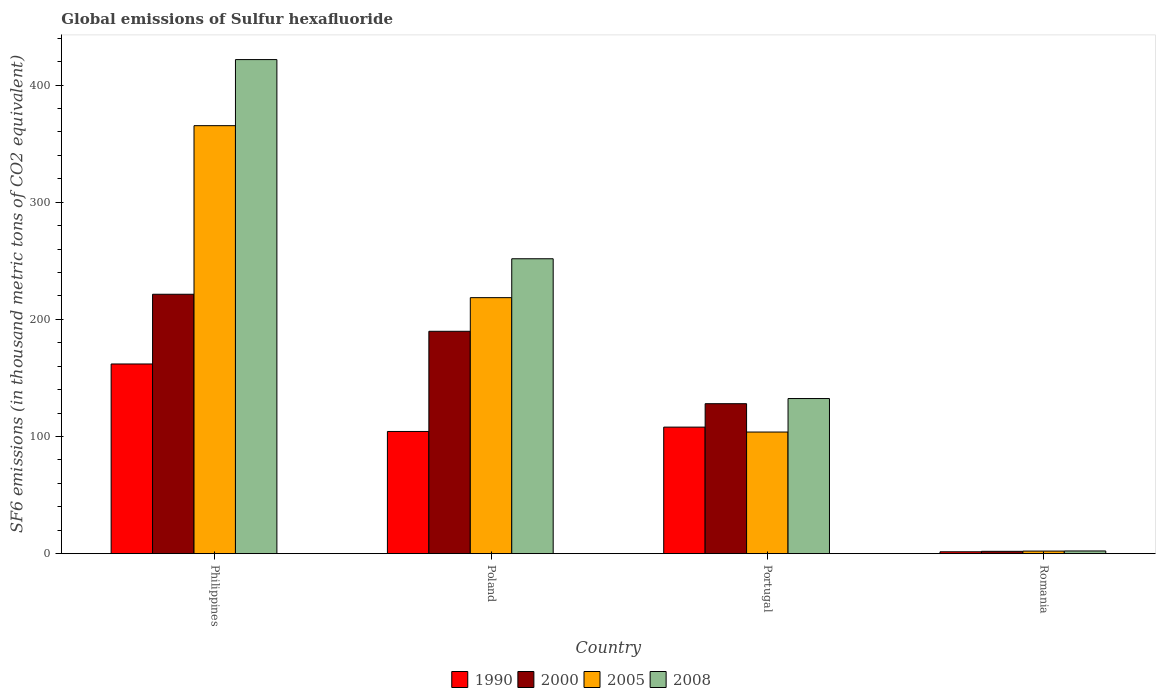Are the number of bars per tick equal to the number of legend labels?
Your answer should be compact. Yes. What is the label of the 3rd group of bars from the left?
Give a very brief answer. Portugal. What is the global emissions of Sulfur hexafluoride in 1990 in Portugal?
Your response must be concise. 108. Across all countries, what is the maximum global emissions of Sulfur hexafluoride in 2008?
Keep it short and to the point. 421.7. Across all countries, what is the minimum global emissions of Sulfur hexafluoride in 2005?
Give a very brief answer. 2.2. In which country was the global emissions of Sulfur hexafluoride in 2008 minimum?
Give a very brief answer. Romania. What is the total global emissions of Sulfur hexafluoride in 1990 in the graph?
Give a very brief answer. 375.8. What is the difference between the global emissions of Sulfur hexafluoride in 2000 in Portugal and that in Romania?
Ensure brevity in your answer.  126. What is the difference between the global emissions of Sulfur hexafluoride in 2008 in Philippines and the global emissions of Sulfur hexafluoride in 2000 in Romania?
Provide a succinct answer. 419.7. What is the average global emissions of Sulfur hexafluoride in 2005 per country?
Your response must be concise. 172.45. What is the difference between the global emissions of Sulfur hexafluoride of/in 2008 and global emissions of Sulfur hexafluoride of/in 1990 in Philippines?
Offer a very short reply. 259.8. In how many countries, is the global emissions of Sulfur hexafluoride in 2000 greater than 280 thousand metric tons?
Your answer should be compact. 0. What is the ratio of the global emissions of Sulfur hexafluoride in 2005 in Portugal to that in Romania?
Give a very brief answer. 47.18. Is the difference between the global emissions of Sulfur hexafluoride in 2008 in Philippines and Poland greater than the difference between the global emissions of Sulfur hexafluoride in 1990 in Philippines and Poland?
Provide a succinct answer. Yes. What is the difference between the highest and the second highest global emissions of Sulfur hexafluoride in 1990?
Your answer should be compact. -57.6. What is the difference between the highest and the lowest global emissions of Sulfur hexafluoride in 2000?
Provide a succinct answer. 219.4. In how many countries, is the global emissions of Sulfur hexafluoride in 2008 greater than the average global emissions of Sulfur hexafluoride in 2008 taken over all countries?
Your answer should be very brief. 2. Is the sum of the global emissions of Sulfur hexafluoride in 2008 in Poland and Portugal greater than the maximum global emissions of Sulfur hexafluoride in 1990 across all countries?
Your answer should be compact. Yes. Is it the case that in every country, the sum of the global emissions of Sulfur hexafluoride in 1990 and global emissions of Sulfur hexafluoride in 2005 is greater than the sum of global emissions of Sulfur hexafluoride in 2008 and global emissions of Sulfur hexafluoride in 2000?
Offer a very short reply. No. What does the 4th bar from the left in Philippines represents?
Your answer should be very brief. 2008. What does the 2nd bar from the right in Philippines represents?
Offer a very short reply. 2005. Is it the case that in every country, the sum of the global emissions of Sulfur hexafluoride in 2000 and global emissions of Sulfur hexafluoride in 2008 is greater than the global emissions of Sulfur hexafluoride in 2005?
Ensure brevity in your answer.  Yes. What is the difference between two consecutive major ticks on the Y-axis?
Your answer should be compact. 100. Does the graph contain any zero values?
Make the answer very short. No. Where does the legend appear in the graph?
Give a very brief answer. Bottom center. What is the title of the graph?
Your answer should be compact. Global emissions of Sulfur hexafluoride. Does "1968" appear as one of the legend labels in the graph?
Offer a terse response. No. What is the label or title of the X-axis?
Ensure brevity in your answer.  Country. What is the label or title of the Y-axis?
Your answer should be very brief. SF6 emissions (in thousand metric tons of CO2 equivalent). What is the SF6 emissions (in thousand metric tons of CO2 equivalent) in 1990 in Philippines?
Your response must be concise. 161.9. What is the SF6 emissions (in thousand metric tons of CO2 equivalent) in 2000 in Philippines?
Offer a very short reply. 221.4. What is the SF6 emissions (in thousand metric tons of CO2 equivalent) in 2005 in Philippines?
Offer a very short reply. 365.3. What is the SF6 emissions (in thousand metric tons of CO2 equivalent) of 2008 in Philippines?
Keep it short and to the point. 421.7. What is the SF6 emissions (in thousand metric tons of CO2 equivalent) of 1990 in Poland?
Your response must be concise. 104.3. What is the SF6 emissions (in thousand metric tons of CO2 equivalent) in 2000 in Poland?
Give a very brief answer. 189.8. What is the SF6 emissions (in thousand metric tons of CO2 equivalent) in 2005 in Poland?
Your response must be concise. 218.5. What is the SF6 emissions (in thousand metric tons of CO2 equivalent) in 2008 in Poland?
Offer a terse response. 251.7. What is the SF6 emissions (in thousand metric tons of CO2 equivalent) in 1990 in Portugal?
Ensure brevity in your answer.  108. What is the SF6 emissions (in thousand metric tons of CO2 equivalent) in 2000 in Portugal?
Your answer should be compact. 128. What is the SF6 emissions (in thousand metric tons of CO2 equivalent) of 2005 in Portugal?
Your answer should be very brief. 103.8. What is the SF6 emissions (in thousand metric tons of CO2 equivalent) of 2008 in Portugal?
Ensure brevity in your answer.  132.4. What is the SF6 emissions (in thousand metric tons of CO2 equivalent) in 2008 in Romania?
Provide a succinct answer. 2.3. Across all countries, what is the maximum SF6 emissions (in thousand metric tons of CO2 equivalent) in 1990?
Your response must be concise. 161.9. Across all countries, what is the maximum SF6 emissions (in thousand metric tons of CO2 equivalent) in 2000?
Offer a very short reply. 221.4. Across all countries, what is the maximum SF6 emissions (in thousand metric tons of CO2 equivalent) of 2005?
Provide a succinct answer. 365.3. Across all countries, what is the maximum SF6 emissions (in thousand metric tons of CO2 equivalent) of 2008?
Make the answer very short. 421.7. Across all countries, what is the minimum SF6 emissions (in thousand metric tons of CO2 equivalent) of 1990?
Offer a very short reply. 1.6. Across all countries, what is the minimum SF6 emissions (in thousand metric tons of CO2 equivalent) in 2000?
Give a very brief answer. 2. Across all countries, what is the minimum SF6 emissions (in thousand metric tons of CO2 equivalent) of 2005?
Keep it short and to the point. 2.2. What is the total SF6 emissions (in thousand metric tons of CO2 equivalent) in 1990 in the graph?
Your response must be concise. 375.8. What is the total SF6 emissions (in thousand metric tons of CO2 equivalent) of 2000 in the graph?
Provide a short and direct response. 541.2. What is the total SF6 emissions (in thousand metric tons of CO2 equivalent) in 2005 in the graph?
Offer a very short reply. 689.8. What is the total SF6 emissions (in thousand metric tons of CO2 equivalent) in 2008 in the graph?
Your answer should be compact. 808.1. What is the difference between the SF6 emissions (in thousand metric tons of CO2 equivalent) in 1990 in Philippines and that in Poland?
Provide a short and direct response. 57.6. What is the difference between the SF6 emissions (in thousand metric tons of CO2 equivalent) of 2000 in Philippines and that in Poland?
Your answer should be compact. 31.6. What is the difference between the SF6 emissions (in thousand metric tons of CO2 equivalent) in 2005 in Philippines and that in Poland?
Your answer should be compact. 146.8. What is the difference between the SF6 emissions (in thousand metric tons of CO2 equivalent) of 2008 in Philippines and that in Poland?
Make the answer very short. 170. What is the difference between the SF6 emissions (in thousand metric tons of CO2 equivalent) in 1990 in Philippines and that in Portugal?
Your response must be concise. 53.9. What is the difference between the SF6 emissions (in thousand metric tons of CO2 equivalent) of 2000 in Philippines and that in Portugal?
Give a very brief answer. 93.4. What is the difference between the SF6 emissions (in thousand metric tons of CO2 equivalent) in 2005 in Philippines and that in Portugal?
Provide a succinct answer. 261.5. What is the difference between the SF6 emissions (in thousand metric tons of CO2 equivalent) of 2008 in Philippines and that in Portugal?
Offer a terse response. 289.3. What is the difference between the SF6 emissions (in thousand metric tons of CO2 equivalent) in 1990 in Philippines and that in Romania?
Ensure brevity in your answer.  160.3. What is the difference between the SF6 emissions (in thousand metric tons of CO2 equivalent) of 2000 in Philippines and that in Romania?
Keep it short and to the point. 219.4. What is the difference between the SF6 emissions (in thousand metric tons of CO2 equivalent) of 2005 in Philippines and that in Romania?
Keep it short and to the point. 363.1. What is the difference between the SF6 emissions (in thousand metric tons of CO2 equivalent) of 2008 in Philippines and that in Romania?
Your answer should be very brief. 419.4. What is the difference between the SF6 emissions (in thousand metric tons of CO2 equivalent) in 2000 in Poland and that in Portugal?
Ensure brevity in your answer.  61.8. What is the difference between the SF6 emissions (in thousand metric tons of CO2 equivalent) of 2005 in Poland and that in Portugal?
Offer a terse response. 114.7. What is the difference between the SF6 emissions (in thousand metric tons of CO2 equivalent) of 2008 in Poland and that in Portugal?
Keep it short and to the point. 119.3. What is the difference between the SF6 emissions (in thousand metric tons of CO2 equivalent) of 1990 in Poland and that in Romania?
Your response must be concise. 102.7. What is the difference between the SF6 emissions (in thousand metric tons of CO2 equivalent) in 2000 in Poland and that in Romania?
Ensure brevity in your answer.  187.8. What is the difference between the SF6 emissions (in thousand metric tons of CO2 equivalent) in 2005 in Poland and that in Romania?
Provide a succinct answer. 216.3. What is the difference between the SF6 emissions (in thousand metric tons of CO2 equivalent) in 2008 in Poland and that in Romania?
Your answer should be compact. 249.4. What is the difference between the SF6 emissions (in thousand metric tons of CO2 equivalent) in 1990 in Portugal and that in Romania?
Give a very brief answer. 106.4. What is the difference between the SF6 emissions (in thousand metric tons of CO2 equivalent) of 2000 in Portugal and that in Romania?
Offer a terse response. 126. What is the difference between the SF6 emissions (in thousand metric tons of CO2 equivalent) in 2005 in Portugal and that in Romania?
Provide a succinct answer. 101.6. What is the difference between the SF6 emissions (in thousand metric tons of CO2 equivalent) of 2008 in Portugal and that in Romania?
Make the answer very short. 130.1. What is the difference between the SF6 emissions (in thousand metric tons of CO2 equivalent) of 1990 in Philippines and the SF6 emissions (in thousand metric tons of CO2 equivalent) of 2000 in Poland?
Your answer should be compact. -27.9. What is the difference between the SF6 emissions (in thousand metric tons of CO2 equivalent) of 1990 in Philippines and the SF6 emissions (in thousand metric tons of CO2 equivalent) of 2005 in Poland?
Ensure brevity in your answer.  -56.6. What is the difference between the SF6 emissions (in thousand metric tons of CO2 equivalent) of 1990 in Philippines and the SF6 emissions (in thousand metric tons of CO2 equivalent) of 2008 in Poland?
Your answer should be very brief. -89.8. What is the difference between the SF6 emissions (in thousand metric tons of CO2 equivalent) in 2000 in Philippines and the SF6 emissions (in thousand metric tons of CO2 equivalent) in 2005 in Poland?
Provide a succinct answer. 2.9. What is the difference between the SF6 emissions (in thousand metric tons of CO2 equivalent) in 2000 in Philippines and the SF6 emissions (in thousand metric tons of CO2 equivalent) in 2008 in Poland?
Your answer should be compact. -30.3. What is the difference between the SF6 emissions (in thousand metric tons of CO2 equivalent) of 2005 in Philippines and the SF6 emissions (in thousand metric tons of CO2 equivalent) of 2008 in Poland?
Your response must be concise. 113.6. What is the difference between the SF6 emissions (in thousand metric tons of CO2 equivalent) in 1990 in Philippines and the SF6 emissions (in thousand metric tons of CO2 equivalent) in 2000 in Portugal?
Your answer should be very brief. 33.9. What is the difference between the SF6 emissions (in thousand metric tons of CO2 equivalent) in 1990 in Philippines and the SF6 emissions (in thousand metric tons of CO2 equivalent) in 2005 in Portugal?
Give a very brief answer. 58.1. What is the difference between the SF6 emissions (in thousand metric tons of CO2 equivalent) in 1990 in Philippines and the SF6 emissions (in thousand metric tons of CO2 equivalent) in 2008 in Portugal?
Keep it short and to the point. 29.5. What is the difference between the SF6 emissions (in thousand metric tons of CO2 equivalent) of 2000 in Philippines and the SF6 emissions (in thousand metric tons of CO2 equivalent) of 2005 in Portugal?
Your response must be concise. 117.6. What is the difference between the SF6 emissions (in thousand metric tons of CO2 equivalent) in 2000 in Philippines and the SF6 emissions (in thousand metric tons of CO2 equivalent) in 2008 in Portugal?
Make the answer very short. 89. What is the difference between the SF6 emissions (in thousand metric tons of CO2 equivalent) in 2005 in Philippines and the SF6 emissions (in thousand metric tons of CO2 equivalent) in 2008 in Portugal?
Your answer should be very brief. 232.9. What is the difference between the SF6 emissions (in thousand metric tons of CO2 equivalent) in 1990 in Philippines and the SF6 emissions (in thousand metric tons of CO2 equivalent) in 2000 in Romania?
Provide a short and direct response. 159.9. What is the difference between the SF6 emissions (in thousand metric tons of CO2 equivalent) in 1990 in Philippines and the SF6 emissions (in thousand metric tons of CO2 equivalent) in 2005 in Romania?
Offer a very short reply. 159.7. What is the difference between the SF6 emissions (in thousand metric tons of CO2 equivalent) in 1990 in Philippines and the SF6 emissions (in thousand metric tons of CO2 equivalent) in 2008 in Romania?
Provide a short and direct response. 159.6. What is the difference between the SF6 emissions (in thousand metric tons of CO2 equivalent) of 2000 in Philippines and the SF6 emissions (in thousand metric tons of CO2 equivalent) of 2005 in Romania?
Give a very brief answer. 219.2. What is the difference between the SF6 emissions (in thousand metric tons of CO2 equivalent) in 2000 in Philippines and the SF6 emissions (in thousand metric tons of CO2 equivalent) in 2008 in Romania?
Your response must be concise. 219.1. What is the difference between the SF6 emissions (in thousand metric tons of CO2 equivalent) of 2005 in Philippines and the SF6 emissions (in thousand metric tons of CO2 equivalent) of 2008 in Romania?
Offer a very short reply. 363. What is the difference between the SF6 emissions (in thousand metric tons of CO2 equivalent) in 1990 in Poland and the SF6 emissions (in thousand metric tons of CO2 equivalent) in 2000 in Portugal?
Offer a very short reply. -23.7. What is the difference between the SF6 emissions (in thousand metric tons of CO2 equivalent) of 1990 in Poland and the SF6 emissions (in thousand metric tons of CO2 equivalent) of 2005 in Portugal?
Your answer should be compact. 0.5. What is the difference between the SF6 emissions (in thousand metric tons of CO2 equivalent) of 1990 in Poland and the SF6 emissions (in thousand metric tons of CO2 equivalent) of 2008 in Portugal?
Keep it short and to the point. -28.1. What is the difference between the SF6 emissions (in thousand metric tons of CO2 equivalent) in 2000 in Poland and the SF6 emissions (in thousand metric tons of CO2 equivalent) in 2005 in Portugal?
Your answer should be very brief. 86. What is the difference between the SF6 emissions (in thousand metric tons of CO2 equivalent) of 2000 in Poland and the SF6 emissions (in thousand metric tons of CO2 equivalent) of 2008 in Portugal?
Offer a very short reply. 57.4. What is the difference between the SF6 emissions (in thousand metric tons of CO2 equivalent) in 2005 in Poland and the SF6 emissions (in thousand metric tons of CO2 equivalent) in 2008 in Portugal?
Keep it short and to the point. 86.1. What is the difference between the SF6 emissions (in thousand metric tons of CO2 equivalent) of 1990 in Poland and the SF6 emissions (in thousand metric tons of CO2 equivalent) of 2000 in Romania?
Your response must be concise. 102.3. What is the difference between the SF6 emissions (in thousand metric tons of CO2 equivalent) in 1990 in Poland and the SF6 emissions (in thousand metric tons of CO2 equivalent) in 2005 in Romania?
Offer a very short reply. 102.1. What is the difference between the SF6 emissions (in thousand metric tons of CO2 equivalent) of 1990 in Poland and the SF6 emissions (in thousand metric tons of CO2 equivalent) of 2008 in Romania?
Give a very brief answer. 102. What is the difference between the SF6 emissions (in thousand metric tons of CO2 equivalent) of 2000 in Poland and the SF6 emissions (in thousand metric tons of CO2 equivalent) of 2005 in Romania?
Ensure brevity in your answer.  187.6. What is the difference between the SF6 emissions (in thousand metric tons of CO2 equivalent) of 2000 in Poland and the SF6 emissions (in thousand metric tons of CO2 equivalent) of 2008 in Romania?
Your answer should be very brief. 187.5. What is the difference between the SF6 emissions (in thousand metric tons of CO2 equivalent) of 2005 in Poland and the SF6 emissions (in thousand metric tons of CO2 equivalent) of 2008 in Romania?
Offer a very short reply. 216.2. What is the difference between the SF6 emissions (in thousand metric tons of CO2 equivalent) of 1990 in Portugal and the SF6 emissions (in thousand metric tons of CO2 equivalent) of 2000 in Romania?
Give a very brief answer. 106. What is the difference between the SF6 emissions (in thousand metric tons of CO2 equivalent) of 1990 in Portugal and the SF6 emissions (in thousand metric tons of CO2 equivalent) of 2005 in Romania?
Your answer should be compact. 105.8. What is the difference between the SF6 emissions (in thousand metric tons of CO2 equivalent) in 1990 in Portugal and the SF6 emissions (in thousand metric tons of CO2 equivalent) in 2008 in Romania?
Your answer should be compact. 105.7. What is the difference between the SF6 emissions (in thousand metric tons of CO2 equivalent) in 2000 in Portugal and the SF6 emissions (in thousand metric tons of CO2 equivalent) in 2005 in Romania?
Ensure brevity in your answer.  125.8. What is the difference between the SF6 emissions (in thousand metric tons of CO2 equivalent) in 2000 in Portugal and the SF6 emissions (in thousand metric tons of CO2 equivalent) in 2008 in Romania?
Provide a short and direct response. 125.7. What is the difference between the SF6 emissions (in thousand metric tons of CO2 equivalent) of 2005 in Portugal and the SF6 emissions (in thousand metric tons of CO2 equivalent) of 2008 in Romania?
Provide a short and direct response. 101.5. What is the average SF6 emissions (in thousand metric tons of CO2 equivalent) in 1990 per country?
Keep it short and to the point. 93.95. What is the average SF6 emissions (in thousand metric tons of CO2 equivalent) of 2000 per country?
Make the answer very short. 135.3. What is the average SF6 emissions (in thousand metric tons of CO2 equivalent) of 2005 per country?
Ensure brevity in your answer.  172.45. What is the average SF6 emissions (in thousand metric tons of CO2 equivalent) of 2008 per country?
Your answer should be very brief. 202.03. What is the difference between the SF6 emissions (in thousand metric tons of CO2 equivalent) of 1990 and SF6 emissions (in thousand metric tons of CO2 equivalent) of 2000 in Philippines?
Your answer should be compact. -59.5. What is the difference between the SF6 emissions (in thousand metric tons of CO2 equivalent) in 1990 and SF6 emissions (in thousand metric tons of CO2 equivalent) in 2005 in Philippines?
Give a very brief answer. -203.4. What is the difference between the SF6 emissions (in thousand metric tons of CO2 equivalent) in 1990 and SF6 emissions (in thousand metric tons of CO2 equivalent) in 2008 in Philippines?
Give a very brief answer. -259.8. What is the difference between the SF6 emissions (in thousand metric tons of CO2 equivalent) in 2000 and SF6 emissions (in thousand metric tons of CO2 equivalent) in 2005 in Philippines?
Your answer should be compact. -143.9. What is the difference between the SF6 emissions (in thousand metric tons of CO2 equivalent) of 2000 and SF6 emissions (in thousand metric tons of CO2 equivalent) of 2008 in Philippines?
Your answer should be compact. -200.3. What is the difference between the SF6 emissions (in thousand metric tons of CO2 equivalent) of 2005 and SF6 emissions (in thousand metric tons of CO2 equivalent) of 2008 in Philippines?
Your response must be concise. -56.4. What is the difference between the SF6 emissions (in thousand metric tons of CO2 equivalent) in 1990 and SF6 emissions (in thousand metric tons of CO2 equivalent) in 2000 in Poland?
Offer a terse response. -85.5. What is the difference between the SF6 emissions (in thousand metric tons of CO2 equivalent) of 1990 and SF6 emissions (in thousand metric tons of CO2 equivalent) of 2005 in Poland?
Your response must be concise. -114.2. What is the difference between the SF6 emissions (in thousand metric tons of CO2 equivalent) of 1990 and SF6 emissions (in thousand metric tons of CO2 equivalent) of 2008 in Poland?
Provide a short and direct response. -147.4. What is the difference between the SF6 emissions (in thousand metric tons of CO2 equivalent) of 2000 and SF6 emissions (in thousand metric tons of CO2 equivalent) of 2005 in Poland?
Your answer should be compact. -28.7. What is the difference between the SF6 emissions (in thousand metric tons of CO2 equivalent) in 2000 and SF6 emissions (in thousand metric tons of CO2 equivalent) in 2008 in Poland?
Your answer should be compact. -61.9. What is the difference between the SF6 emissions (in thousand metric tons of CO2 equivalent) in 2005 and SF6 emissions (in thousand metric tons of CO2 equivalent) in 2008 in Poland?
Keep it short and to the point. -33.2. What is the difference between the SF6 emissions (in thousand metric tons of CO2 equivalent) in 1990 and SF6 emissions (in thousand metric tons of CO2 equivalent) in 2000 in Portugal?
Ensure brevity in your answer.  -20. What is the difference between the SF6 emissions (in thousand metric tons of CO2 equivalent) in 1990 and SF6 emissions (in thousand metric tons of CO2 equivalent) in 2008 in Portugal?
Provide a short and direct response. -24.4. What is the difference between the SF6 emissions (in thousand metric tons of CO2 equivalent) in 2000 and SF6 emissions (in thousand metric tons of CO2 equivalent) in 2005 in Portugal?
Make the answer very short. 24.2. What is the difference between the SF6 emissions (in thousand metric tons of CO2 equivalent) in 2005 and SF6 emissions (in thousand metric tons of CO2 equivalent) in 2008 in Portugal?
Provide a succinct answer. -28.6. What is the difference between the SF6 emissions (in thousand metric tons of CO2 equivalent) of 1990 and SF6 emissions (in thousand metric tons of CO2 equivalent) of 2000 in Romania?
Offer a very short reply. -0.4. What is the difference between the SF6 emissions (in thousand metric tons of CO2 equivalent) in 1990 and SF6 emissions (in thousand metric tons of CO2 equivalent) in 2008 in Romania?
Provide a succinct answer. -0.7. What is the ratio of the SF6 emissions (in thousand metric tons of CO2 equivalent) in 1990 in Philippines to that in Poland?
Your answer should be very brief. 1.55. What is the ratio of the SF6 emissions (in thousand metric tons of CO2 equivalent) of 2000 in Philippines to that in Poland?
Offer a very short reply. 1.17. What is the ratio of the SF6 emissions (in thousand metric tons of CO2 equivalent) in 2005 in Philippines to that in Poland?
Offer a terse response. 1.67. What is the ratio of the SF6 emissions (in thousand metric tons of CO2 equivalent) in 2008 in Philippines to that in Poland?
Give a very brief answer. 1.68. What is the ratio of the SF6 emissions (in thousand metric tons of CO2 equivalent) of 1990 in Philippines to that in Portugal?
Give a very brief answer. 1.5. What is the ratio of the SF6 emissions (in thousand metric tons of CO2 equivalent) in 2000 in Philippines to that in Portugal?
Offer a terse response. 1.73. What is the ratio of the SF6 emissions (in thousand metric tons of CO2 equivalent) of 2005 in Philippines to that in Portugal?
Your response must be concise. 3.52. What is the ratio of the SF6 emissions (in thousand metric tons of CO2 equivalent) in 2008 in Philippines to that in Portugal?
Provide a short and direct response. 3.19. What is the ratio of the SF6 emissions (in thousand metric tons of CO2 equivalent) of 1990 in Philippines to that in Romania?
Your answer should be compact. 101.19. What is the ratio of the SF6 emissions (in thousand metric tons of CO2 equivalent) in 2000 in Philippines to that in Romania?
Your response must be concise. 110.7. What is the ratio of the SF6 emissions (in thousand metric tons of CO2 equivalent) in 2005 in Philippines to that in Romania?
Provide a short and direct response. 166.05. What is the ratio of the SF6 emissions (in thousand metric tons of CO2 equivalent) in 2008 in Philippines to that in Romania?
Offer a very short reply. 183.35. What is the ratio of the SF6 emissions (in thousand metric tons of CO2 equivalent) of 1990 in Poland to that in Portugal?
Give a very brief answer. 0.97. What is the ratio of the SF6 emissions (in thousand metric tons of CO2 equivalent) of 2000 in Poland to that in Portugal?
Keep it short and to the point. 1.48. What is the ratio of the SF6 emissions (in thousand metric tons of CO2 equivalent) in 2005 in Poland to that in Portugal?
Keep it short and to the point. 2.1. What is the ratio of the SF6 emissions (in thousand metric tons of CO2 equivalent) of 2008 in Poland to that in Portugal?
Provide a succinct answer. 1.9. What is the ratio of the SF6 emissions (in thousand metric tons of CO2 equivalent) in 1990 in Poland to that in Romania?
Offer a terse response. 65.19. What is the ratio of the SF6 emissions (in thousand metric tons of CO2 equivalent) in 2000 in Poland to that in Romania?
Provide a short and direct response. 94.9. What is the ratio of the SF6 emissions (in thousand metric tons of CO2 equivalent) of 2005 in Poland to that in Romania?
Provide a short and direct response. 99.32. What is the ratio of the SF6 emissions (in thousand metric tons of CO2 equivalent) of 2008 in Poland to that in Romania?
Give a very brief answer. 109.43. What is the ratio of the SF6 emissions (in thousand metric tons of CO2 equivalent) of 1990 in Portugal to that in Romania?
Offer a very short reply. 67.5. What is the ratio of the SF6 emissions (in thousand metric tons of CO2 equivalent) of 2000 in Portugal to that in Romania?
Keep it short and to the point. 64. What is the ratio of the SF6 emissions (in thousand metric tons of CO2 equivalent) of 2005 in Portugal to that in Romania?
Your answer should be very brief. 47.18. What is the ratio of the SF6 emissions (in thousand metric tons of CO2 equivalent) in 2008 in Portugal to that in Romania?
Your answer should be very brief. 57.57. What is the difference between the highest and the second highest SF6 emissions (in thousand metric tons of CO2 equivalent) in 1990?
Your response must be concise. 53.9. What is the difference between the highest and the second highest SF6 emissions (in thousand metric tons of CO2 equivalent) of 2000?
Ensure brevity in your answer.  31.6. What is the difference between the highest and the second highest SF6 emissions (in thousand metric tons of CO2 equivalent) of 2005?
Ensure brevity in your answer.  146.8. What is the difference between the highest and the second highest SF6 emissions (in thousand metric tons of CO2 equivalent) in 2008?
Your answer should be compact. 170. What is the difference between the highest and the lowest SF6 emissions (in thousand metric tons of CO2 equivalent) in 1990?
Keep it short and to the point. 160.3. What is the difference between the highest and the lowest SF6 emissions (in thousand metric tons of CO2 equivalent) in 2000?
Offer a terse response. 219.4. What is the difference between the highest and the lowest SF6 emissions (in thousand metric tons of CO2 equivalent) of 2005?
Offer a very short reply. 363.1. What is the difference between the highest and the lowest SF6 emissions (in thousand metric tons of CO2 equivalent) of 2008?
Provide a short and direct response. 419.4. 